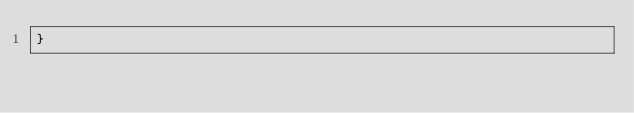<code> <loc_0><loc_0><loc_500><loc_500><_TypeScript_>}
</code> 